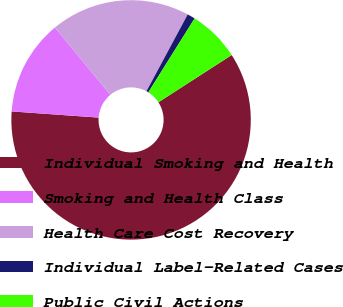Convert chart. <chart><loc_0><loc_0><loc_500><loc_500><pie_chart><fcel>Individual Smoking and Health<fcel>Smoking and Health Class<fcel>Health Care Cost Recovery<fcel>Individual Label-Related Cases<fcel>Public Civil Actions<nl><fcel>60.25%<fcel>12.9%<fcel>18.82%<fcel>1.06%<fcel>6.98%<nl></chart> 